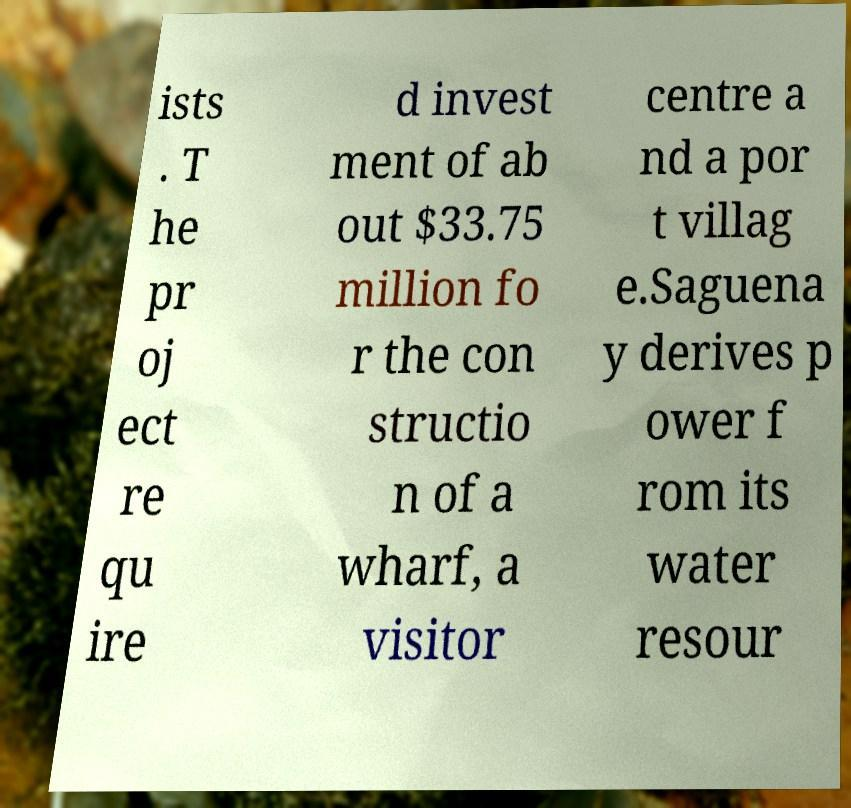There's text embedded in this image that I need extracted. Can you transcribe it verbatim? ists . T he pr oj ect re qu ire d invest ment of ab out $33.75 million fo r the con structio n of a wharf, a visitor centre a nd a por t villag e.Saguena y derives p ower f rom its water resour 